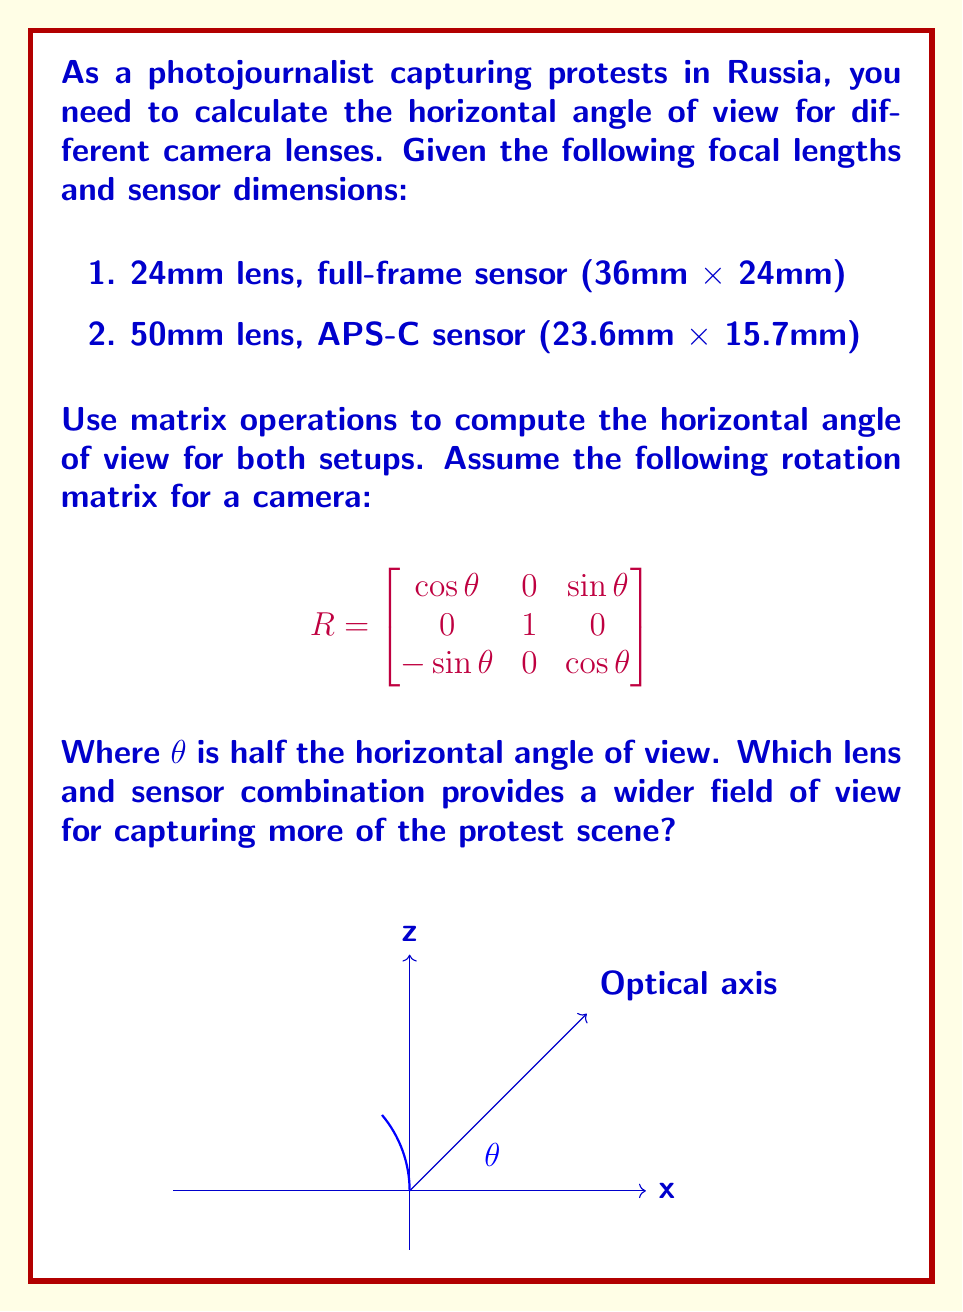Show me your answer to this math problem. To solve this problem, we'll use the formula for the angle of view:

$$\text{AOV} = 2 \arctan\left(\frac{\text{sensor width}}{2f}\right)$$

Where $f$ is the focal length.

1. For the 24mm lens with full-frame sensor:
   Sensor width = 36mm
   $\theta = \arctan\left(\frac{36}{2 \cdot 24}\right) = \arctan(0.75) \approx 36.87°$
   Horizontal AOV = $2 \theta \approx 73.74°$

2. For the 50mm lens with APS-C sensor:
   Sensor width = 23.6mm
   $\theta = \arctan\left(\frac{23.6}{2 \cdot 50}\right) = \arctan(0.236) \approx 13.28°$
   Horizontal AOV = $2 \theta \approx 26.56°$

To express this using matrix operations, we can use the rotation matrix given:

$$R = \begin{bmatrix}
\cos\theta & 0 & \sin\theta \\
0 & 1 & 0 \\
-\sin\theta & 0 & \cos\theta
\end{bmatrix}$$

For the 24mm lens:
$$R_{24mm} = \begin{bmatrix}
\cos(36.87°) & 0 & \sin(36.87°) \\
0 & 1 & 0 \\
-\sin(36.87°) & 0 & \cos(36.87°)
\end{bmatrix} \approx \begin{bmatrix}
0.80 & 0 & 0.60 \\
0 & 1 & 0 \\
-0.60 & 0 & 0.80
\end{bmatrix}$$

For the 50mm lens:
$$R_{50mm} = \begin{bmatrix}
\cos(13.28°) & 0 & \sin(13.28°) \\
0 & 1 & 0 \\
-\sin(13.28°) & 0 & \cos(13.28°)
\end{bmatrix} \approx \begin{bmatrix}
0.97 & 0 & 0.23 \\
0 & 1 & 0 \\
-0.23 & 0 & 0.97
\end{bmatrix}$$

The 24mm lens with the full-frame sensor provides a wider field of view (73.74°) compared to the 50mm lens with the APS-C sensor (26.56°). This setup would be better for capturing more of the protest scene.
Answer: 24mm lens with full-frame sensor (73.74° AOV) 